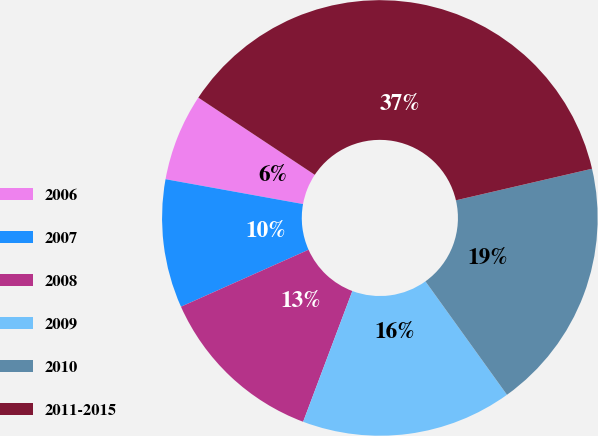<chart> <loc_0><loc_0><loc_500><loc_500><pie_chart><fcel>2006<fcel>2007<fcel>2008<fcel>2009<fcel>2010<fcel>2011-2015<nl><fcel>6.47%<fcel>9.53%<fcel>12.59%<fcel>15.65%<fcel>18.71%<fcel>37.06%<nl></chart> 